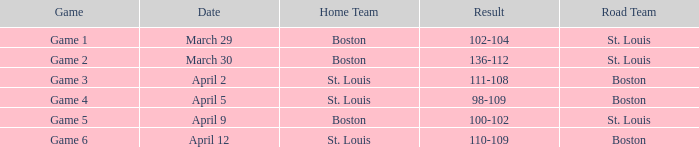What is the match number on april 12 featuring st. louis home team? Game 6. 